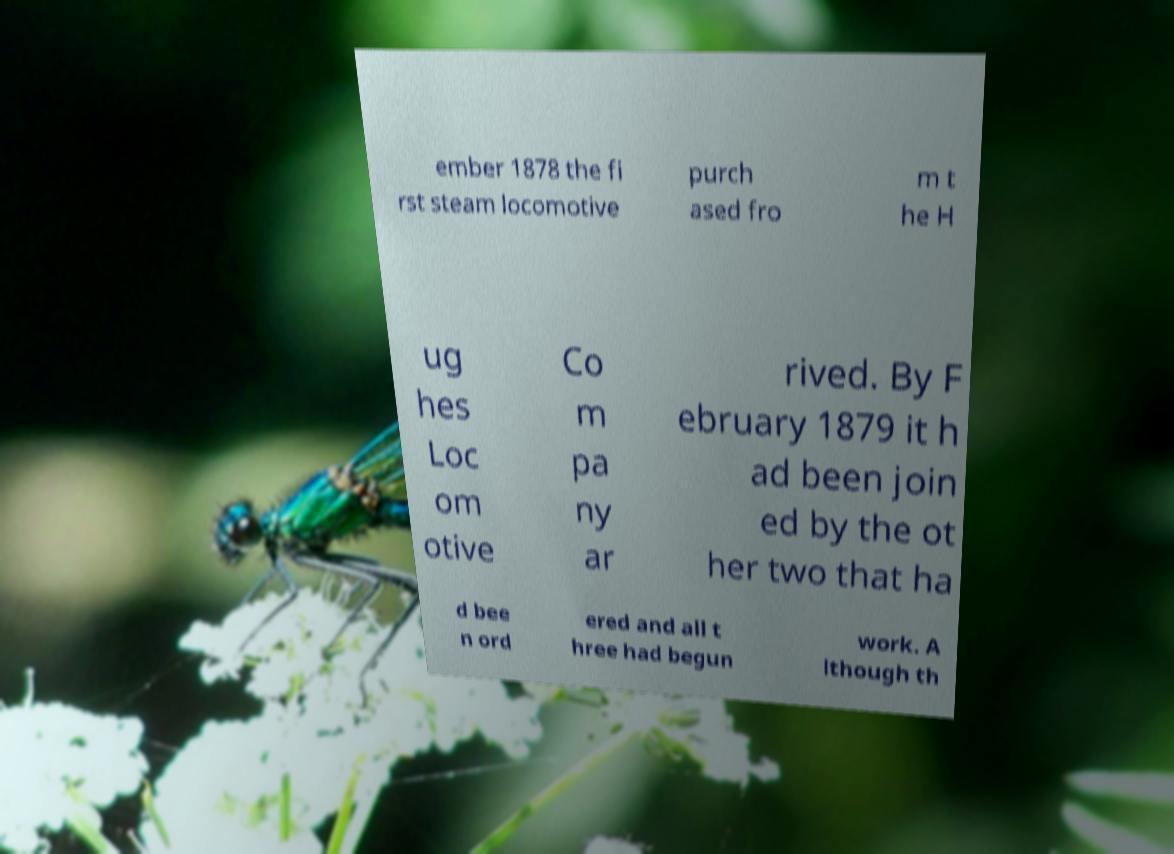Please read and relay the text visible in this image. What does it say? ember 1878 the fi rst steam locomotive purch ased fro m t he H ug hes Loc om otive Co m pa ny ar rived. By F ebruary 1879 it h ad been join ed by the ot her two that ha d bee n ord ered and all t hree had begun work. A lthough th 